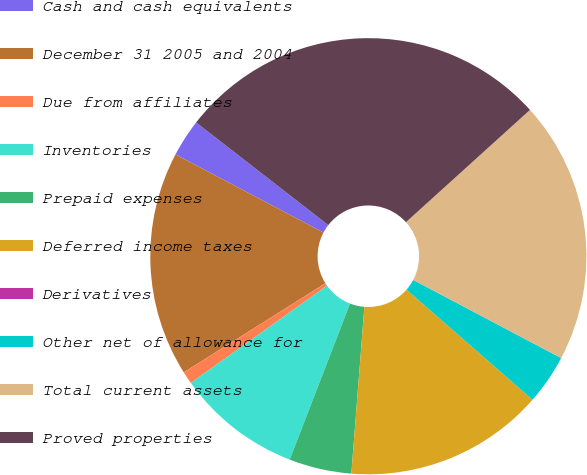Convert chart. <chart><loc_0><loc_0><loc_500><loc_500><pie_chart><fcel>Cash and cash equivalents<fcel>December 31 2005 and 2004<fcel>Due from affiliates<fcel>Inventories<fcel>Prepaid expenses<fcel>Deferred income taxes<fcel>Derivatives<fcel>Other net of allowance for<fcel>Total current assets<fcel>Proved properties<nl><fcel>2.78%<fcel>16.67%<fcel>0.93%<fcel>9.26%<fcel>4.63%<fcel>14.81%<fcel>0.0%<fcel>3.7%<fcel>19.44%<fcel>27.78%<nl></chart> 